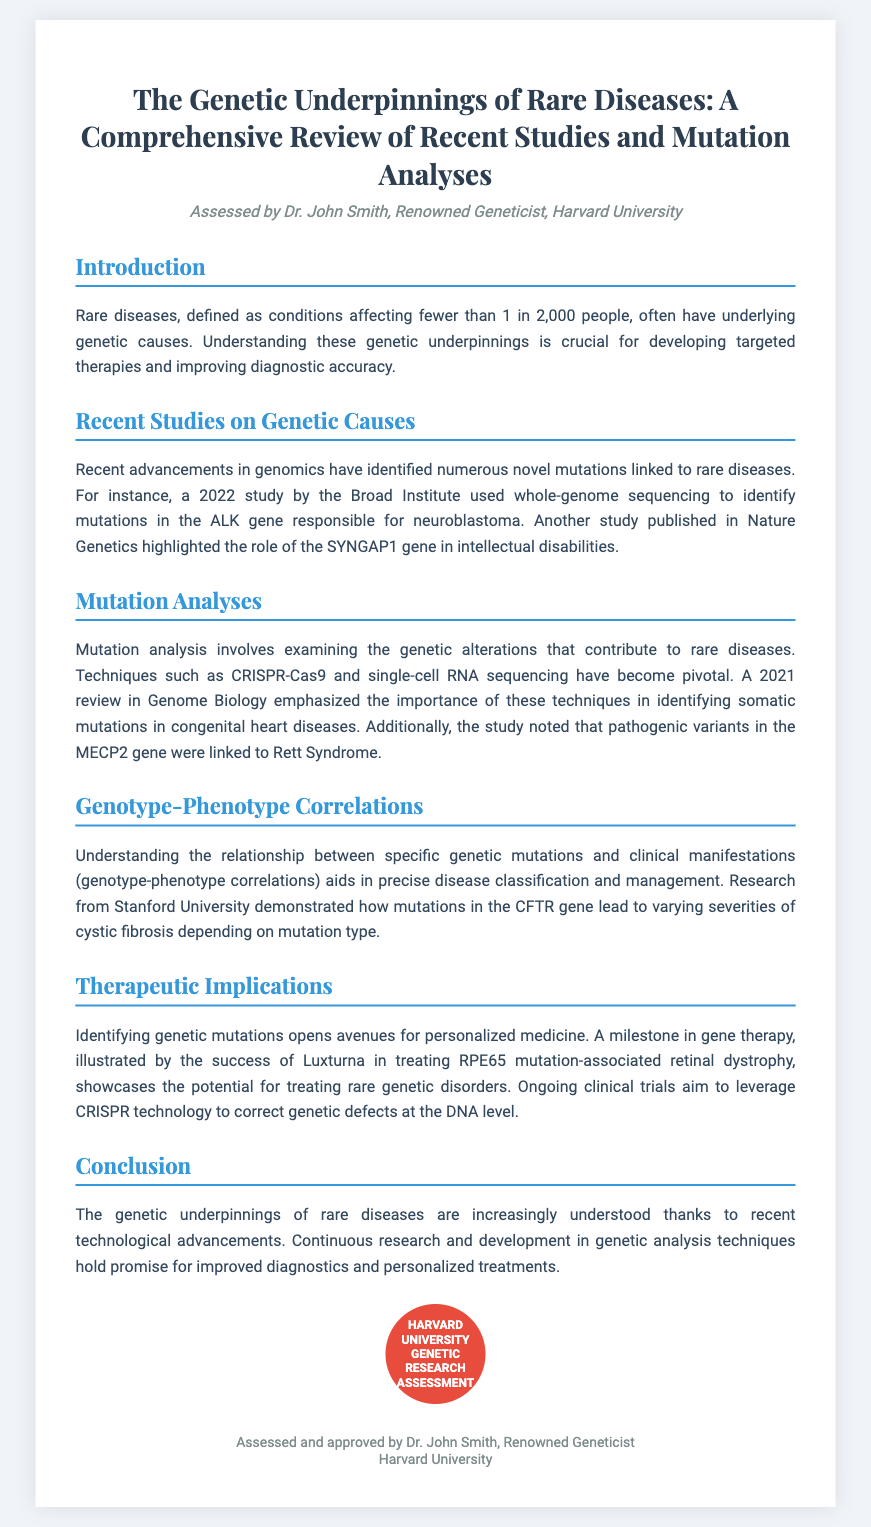what is the title of the diploma? The title of the diploma is presented at the top of the document and is "The Genetic Underpinnings of Rare Diseases: A Comprehensive Review of Recent Studies and Mutation Analyses."
Answer: The Genetic Underpinnings of Rare Diseases: A Comprehensive Review of Recent Studies and Mutation Analyses who assessed the diploma? The name of the assessor is mentioned in the header of the diploma as Dr. John Smith, who is a renowned geneticist at Harvard University.
Answer: Dr. John Smith what are rare diseases defined as? The definition of rare diseases is found in the introduction section, stating they affect fewer than 1 in 2,000 people.
Answer: Fewer than 1 in 2,000 people which gene is associated with neuroblastoma? A study by the Broad Institute identified mutations in the ALK gene responsible for neuroblastoma as noted in the "Recent Studies on Genetic Causes" section.
Answer: ALK gene what technology was emphasized in the mutation analysis for congenital heart diseases? The review in Genome Biology mentioned CRISPR-Cas9 and single-cell RNA sequencing as pivotal techniques for mutation analysis.
Answer: CRISPR-Cas9 and single-cell RNA sequencing what condition is linked to mutations in the MECP2 gene? The document specifies that pathogenic variants in the MECP2 gene are linked to Rett Syndrome.
Answer: Rett Syndrome what is the significance of genotype-phenotype correlations? Genotype-phenotype correlations are explained as aiding in precise disease classification and management, demonstrating their importance in understanding diseases.
Answer: Precise disease classification and management what milestone in gene therapy is highlighted in the therapeutic implications section? The diploma mentions the success of Luxturna in treating RPE65 mutation-associated retinal dystrophy as a significant milestone in gene therapy.
Answer: Luxturna what is the overall conclusion of the diploma? The conclusion summarizes that recent advancements in understanding the genetic underpinnings of rare diseases and their implications for diagnostics and treatments are significant.
Answer: Significant advancements in understanding genetic underpinnings 